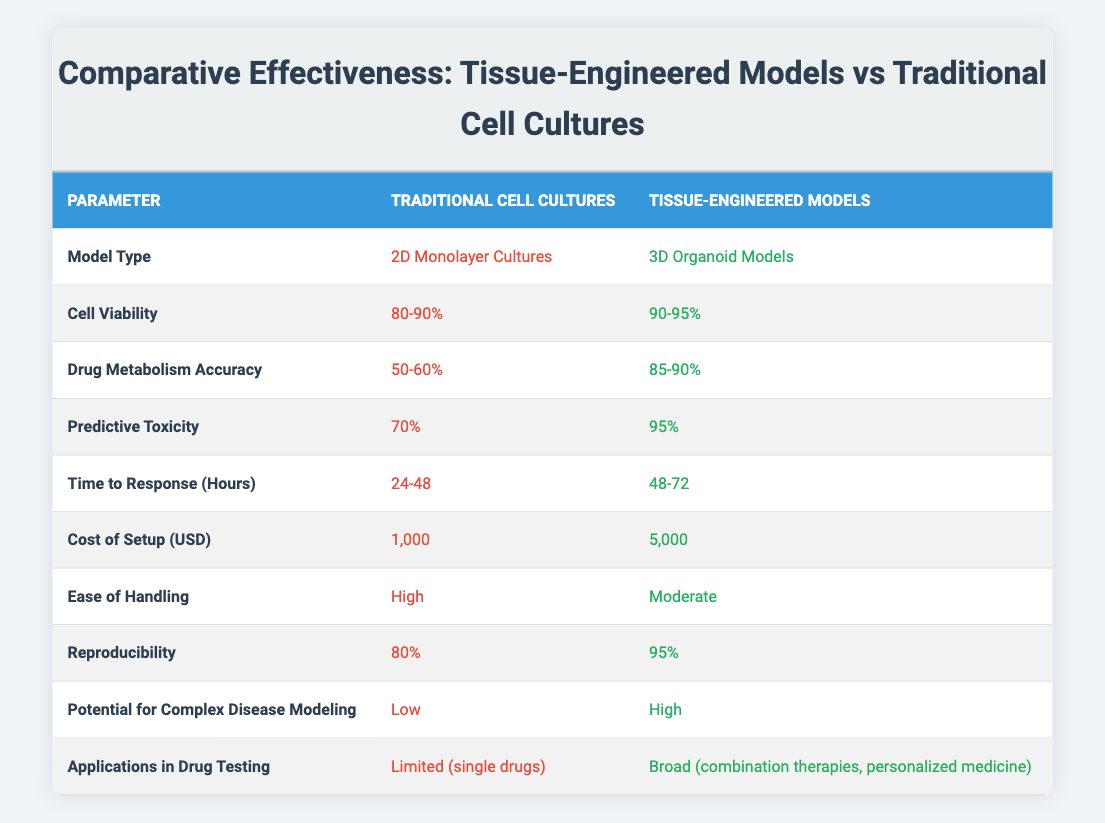What is the cell viability percentage for traditional cell cultures? The table specifies that the cell viability for traditional cell cultures is listed as 80-90%.
Answer: 80-90% What is the cost of setting up tissue-engineered models? According to the table, the cost of setup for tissue-engineered models is stated as 5,000 USD.
Answer: 5,000 USD What is the difference in predictive toxicity between traditional cell cultures and tissue-engineered models? The predictive toxicity for traditional cell cultures is 70%, while for tissue-engineered models it is 95%. The difference is 95% - 70% = 25%.
Answer: 25% Is the drug metabolism accuracy higher in tissue-engineered models than in traditional cell cultures? The table shows that drug metabolism accuracy is 85-90% for tissue-engineered models and only 50-60% for traditional cell cultures, confirming that it is higher in tissue-engineered models.
Answer: Yes What is the average cell viability for both model types? For traditional cell cultures, the average is (80 + 90)/2 = 85%; for tissue-engineered models, the average is (90 + 95)/2 = 92.5%. The combined average is (85 + 92.5)/2 = 88.75%.
Answer: 88.75% How long does it typically take to receive a response with traditional cell cultures? The table indicates that the time to response for traditional cell cultures is between 24-48 hours.
Answer: 24-48 hours Which model has a higher reproducibility percentage? The table indicates that tissue-engineered models have a reproducibility of 95%, while traditional cell cultures have 80%. Tissue-engineered models have a higher reproducibility.
Answer: Tissue-engineered models What is the potential for complex disease modeling in both types of models? The table indicates that traditional cell cultures have low potential for complex disease modeling, whereas tissue-engineered models have high potential.
Answer: Low in traditional, High in engineered If you combine the ease of handling ratings, which model type would emerge as easier to handle? Traditional cell cultures have an ease of handling rated as high, while tissue-engineered models are rated as moderate. Therefore, traditional cell cultures are easier to handle.
Answer: Traditional cell cultures Is the application scope of traditional cell cultures more limited than that of tissue-engineered models? The table states that traditional cell cultures have limited applications (single drugs), whereas tissue-engineered models have broad applications (combination therapies, personalized medicine), confirming the limitation.
Answer: Yes 